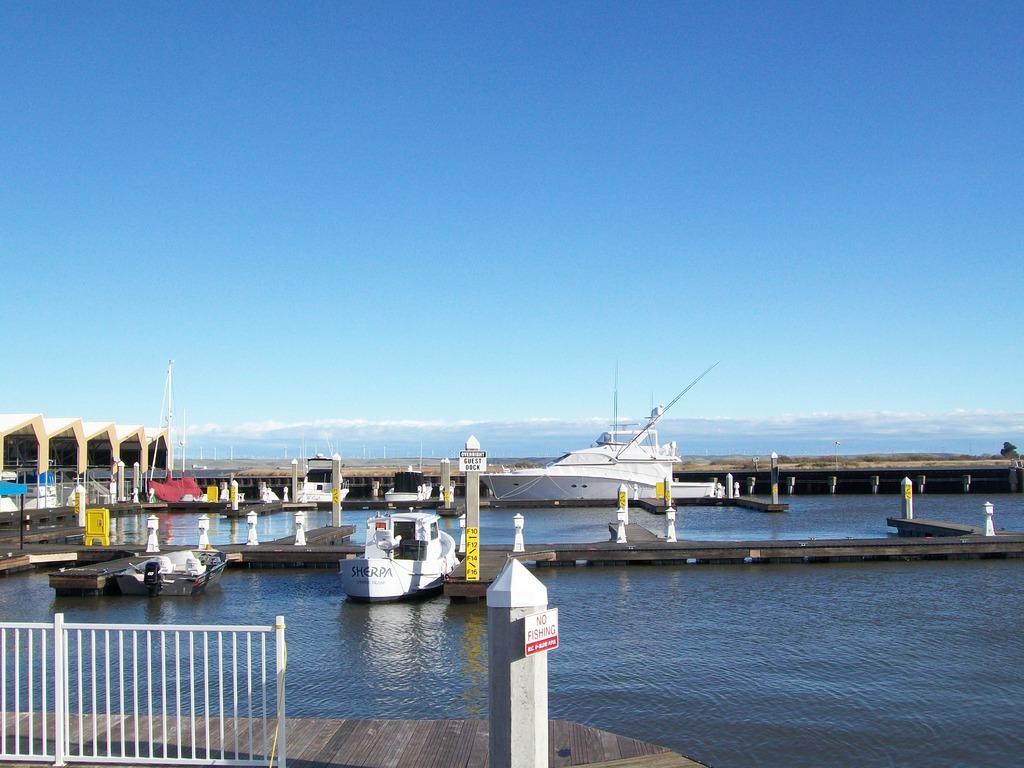Describe this image in one or two sentences. In this picture I can see few boats in the water and I can see foot over bridge and a building on the left side and I can see a tower and I can see a metal fence and a board with some text and I can see a blue sky. 